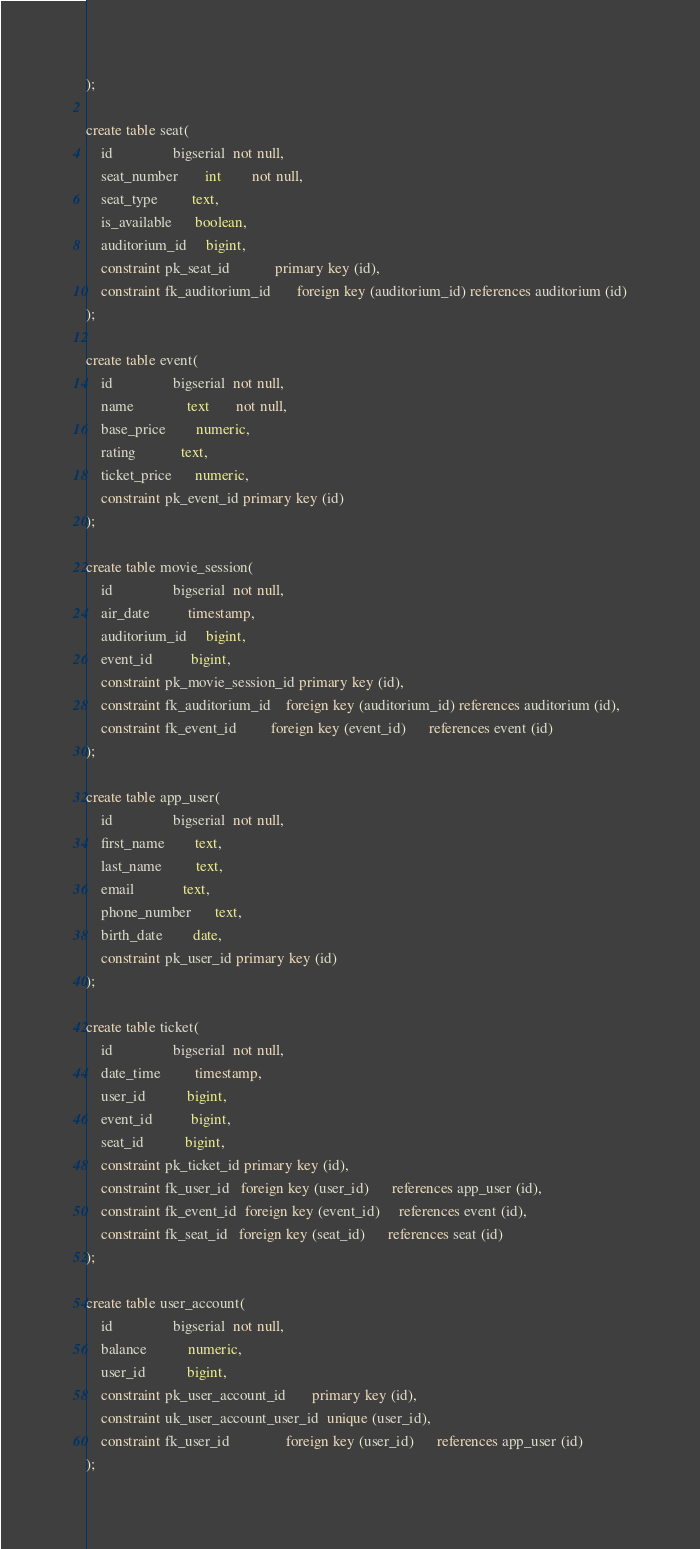<code> <loc_0><loc_0><loc_500><loc_500><_SQL_>);

create table seat(
    id                bigserial  not null,
    seat_number       int        not null,
    seat_type         text,
    is_available      boolean,
    auditorium_id     bigint,
    constraint pk_seat_id            primary key (id),
    constraint fk_auditorium_id       foreign key (auditorium_id) references auditorium (id)
);

create table event(
    id                bigserial  not null,
    name              text       not null,
    base_price        numeric,
    rating            text,
    ticket_price      numeric,
    constraint pk_event_id primary key (id)
);

create table movie_session(
    id                bigserial  not null,
    air_date          timestamp,
    auditorium_id     bigint,
    event_id          bigint,
    constraint pk_movie_session_id primary key (id),
    constraint fk_auditorium_id    foreign key (auditorium_id) references auditorium (id),
    constraint fk_event_id         foreign key (event_id)      references event (id)
);

create table app_user(
    id                bigserial  not null,
    first_name        text,
    last_name         text,
    email             text,
    phone_number      text,
    birth_date        date,
    constraint pk_user_id primary key (id)
);

create table ticket(
    id                bigserial  not null,
    date_time         timestamp,
    user_id           bigint,
    event_id          bigint,
    seat_id           bigint,
    constraint pk_ticket_id primary key (id),
    constraint fk_user_id   foreign key (user_id)      references app_user (id),
    constraint fk_event_id  foreign key (event_id)     references event (id),
    constraint fk_seat_id   foreign key (seat_id)      references seat (id)
);

create table user_account(
    id                bigserial  not null,
    balance           numeric,
    user_id           bigint,
    constraint pk_user_account_id       primary key (id),
    constraint uk_user_account_user_id  unique (user_id),
    constraint fk_user_id               foreign key (user_id)      references app_user (id)
);

</code> 